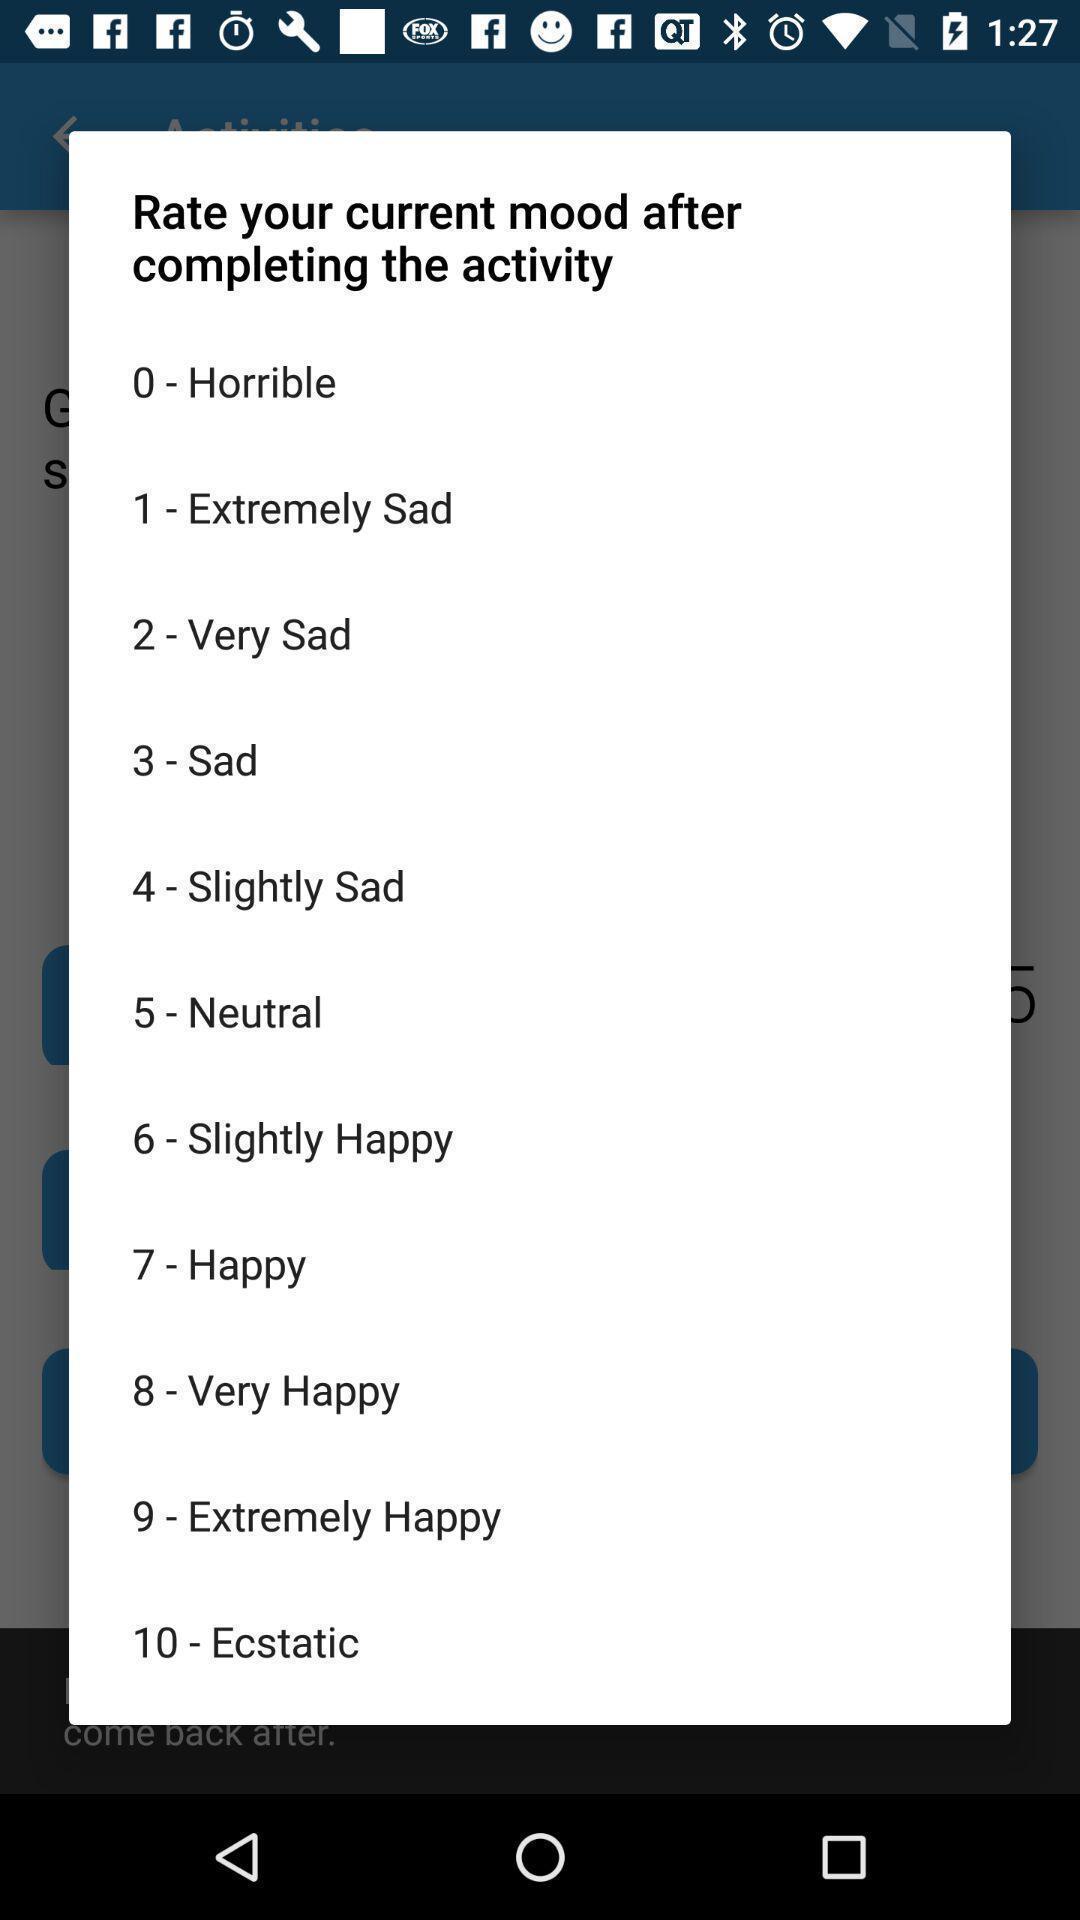Summarize the information in this screenshot. Popup showing about different options. 